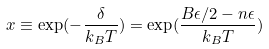<formula> <loc_0><loc_0><loc_500><loc_500>x \equiv \exp ( - \frac { \delta } { k _ { B } T } ) = \exp ( \frac { B \epsilon / 2 - n \epsilon } { k _ { B } T } )</formula> 